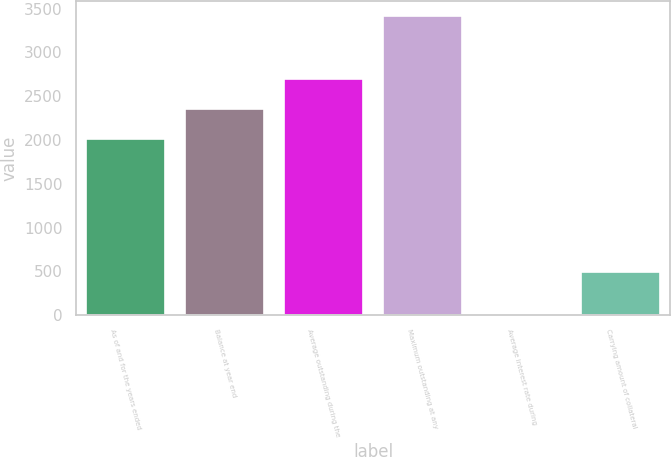<chart> <loc_0><loc_0><loc_500><loc_500><bar_chart><fcel>As of and for the years ended<fcel>Balance at year end<fcel>Average outstanding during the<fcel>Maximum outstanding at any<fcel>Average interest rate during<fcel>Carrying amount of collateral<nl><fcel>2014<fcel>2355.91<fcel>2697.82<fcel>3419.5<fcel>0.36<fcel>495.7<nl></chart> 